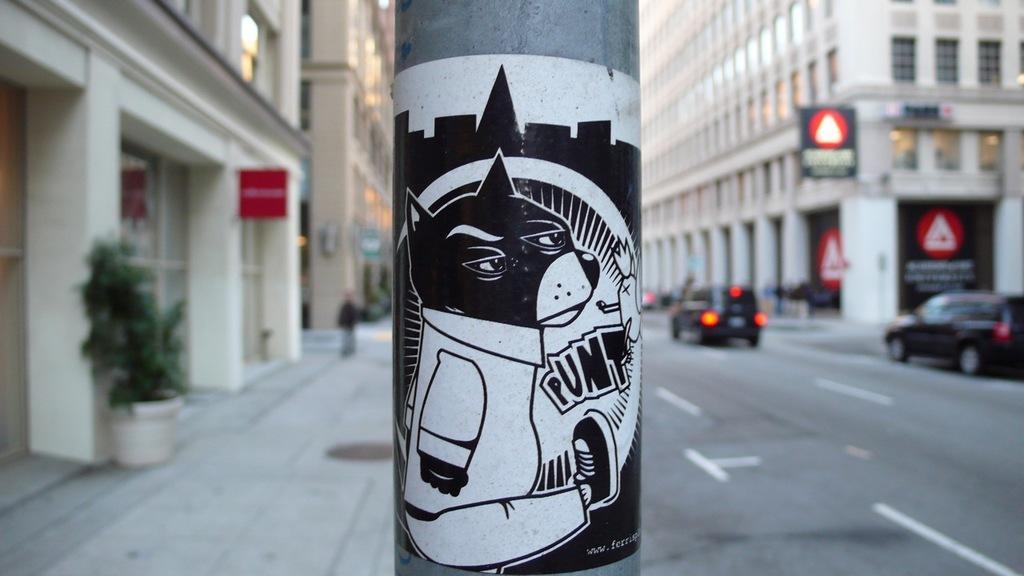In one or two sentences, can you explain what this image depicts? In this image I can see a pole in gray, white and black color. Background I can see few vehicles on the road, buildings in white color. I can also see a person walking and plant in green color. 